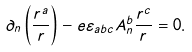<formula> <loc_0><loc_0><loc_500><loc_500>\partial _ { n } \left ( \frac { r ^ { a } } { r } \right ) - e \varepsilon _ { a b c } A _ { n } ^ { b } \frac { r ^ { c } } { r } = 0 .</formula> 